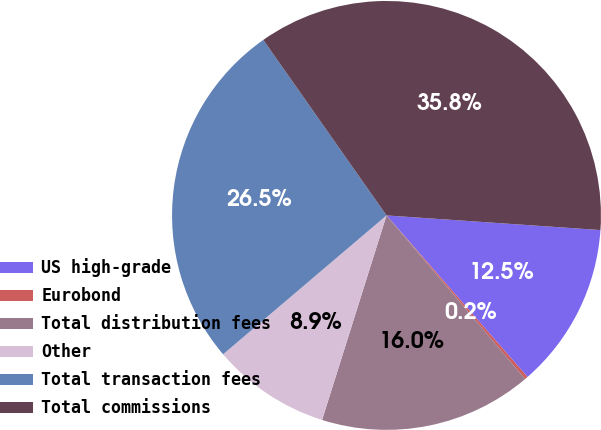Convert chart to OTSL. <chart><loc_0><loc_0><loc_500><loc_500><pie_chart><fcel>US high-grade<fcel>Eurobond<fcel>Total distribution fees<fcel>Other<fcel>Total transaction fees<fcel>Total commissions<nl><fcel>12.49%<fcel>0.23%<fcel>16.05%<fcel>8.93%<fcel>26.47%<fcel>35.83%<nl></chart> 